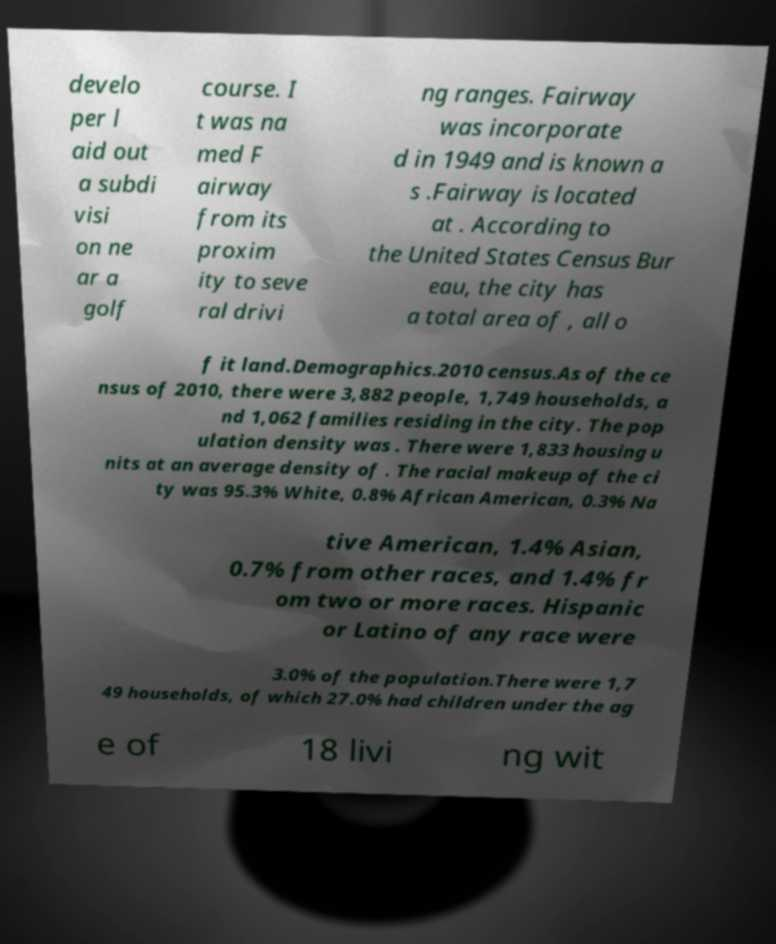Could you assist in decoding the text presented in this image and type it out clearly? develo per l aid out a subdi visi on ne ar a golf course. I t was na med F airway from its proxim ity to seve ral drivi ng ranges. Fairway was incorporate d in 1949 and is known a s .Fairway is located at . According to the United States Census Bur eau, the city has a total area of , all o f it land.Demographics.2010 census.As of the ce nsus of 2010, there were 3,882 people, 1,749 households, a nd 1,062 families residing in the city. The pop ulation density was . There were 1,833 housing u nits at an average density of . The racial makeup of the ci ty was 95.3% White, 0.8% African American, 0.3% Na tive American, 1.4% Asian, 0.7% from other races, and 1.4% fr om two or more races. Hispanic or Latino of any race were 3.0% of the population.There were 1,7 49 households, of which 27.0% had children under the ag e of 18 livi ng wit 